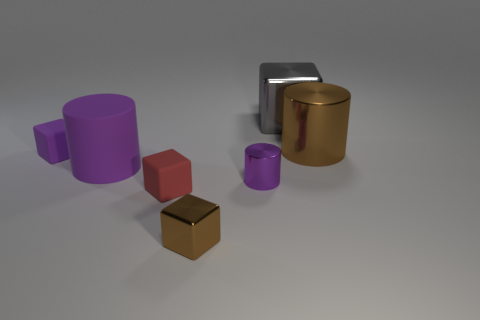How does the lighting in the image affect the appearance of the objects? The soft, diffuse lighting in the image casts gentle shadows and highlights the varying textures of the objects. The metallic cylinders reflect more light, giving them a shiny appearance, while the cubes, which seem to have a more rubber-like texture, absorb light and lack prominent reflections. 